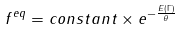<formula> <loc_0><loc_0><loc_500><loc_500>f ^ { e q } = c o n s t a n t \times e ^ { - \frac { E ( \Gamma ) } { \theta } }</formula> 